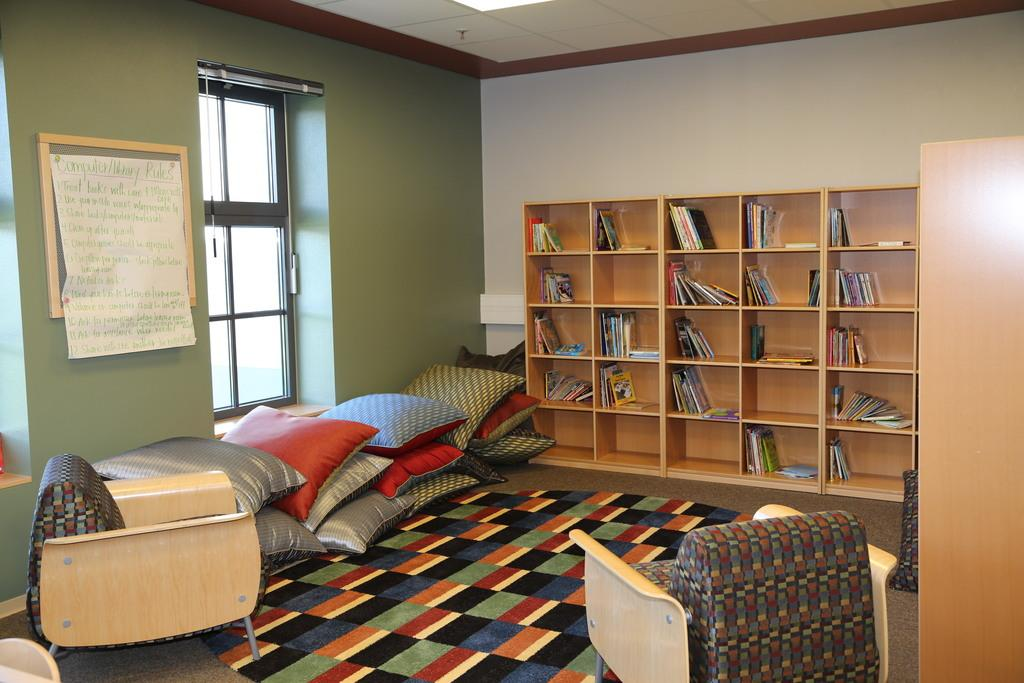Where is the image taken? The image is taken inside a bedroom. What can be found in the room besides the bed? There is a rack with books in the room. What is the position of the windows in the room? The windows are on the wall. What is placed in front of the windows? There is a bed in front of the windows. How many pillows are on the bed? The bed has many pillows on it. What type of religion is practiced in the bedroom according to the image? There is no indication of any religious practice in the image; it simply shows a bedroom with a bed, books, and windows. Can you tell me if the parent is present in the image? There is no person, including a parent, visible in the image. 